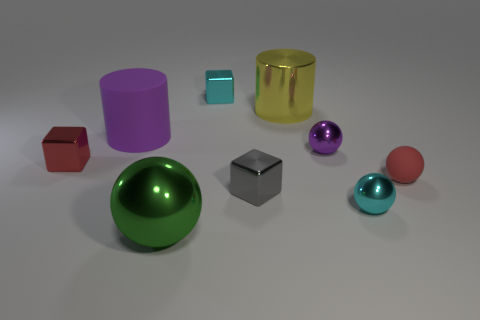What number of red objects are behind the cyan shiny block that is behind the metallic block that is in front of the red ball?
Your response must be concise. 0. What is the object that is both in front of the small gray cube and on the left side of the gray metal object made of?
Give a very brief answer. Metal. Is the material of the cyan cube the same as the ball that is right of the tiny cyan metal ball?
Provide a succinct answer. No. Are there more big yellow cylinders that are on the left side of the small gray metal object than big metal things that are to the right of the purple metallic sphere?
Your answer should be very brief. No. The large yellow thing has what shape?
Ensure brevity in your answer.  Cylinder. Are the small cyan thing right of the purple metallic ball and the tiny sphere behind the rubber sphere made of the same material?
Provide a succinct answer. Yes. There is a cyan thing on the left side of the small purple shiny thing; what shape is it?
Give a very brief answer. Cube. The cyan shiny object that is the same shape as the green metallic thing is what size?
Make the answer very short. Small. Do the tiny rubber ball and the metal cylinder have the same color?
Keep it short and to the point. No. Is there anything else that is the same shape as the small red shiny object?
Your answer should be compact. Yes. 